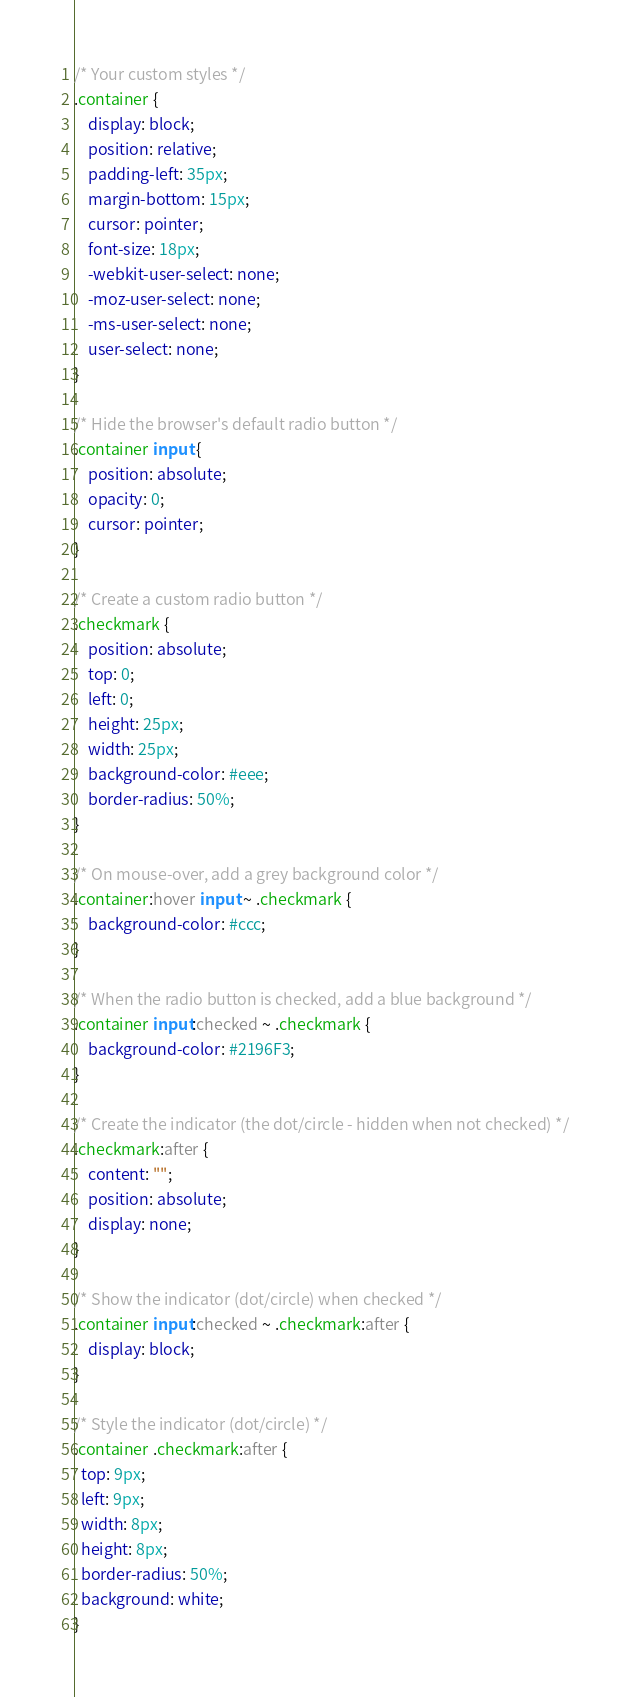<code> <loc_0><loc_0><loc_500><loc_500><_CSS_>/* Your custom styles */
.container {
    display: block;
    position: relative;
    padding-left: 35px;
    margin-bottom: 15px;
    cursor: pointer;
    font-size: 18px;
    -webkit-user-select: none;
    -moz-user-select: none;
    -ms-user-select: none;
    user-select: none;
}

/* Hide the browser's default radio button */
.container input {
    position: absolute;
    opacity: 0;
    cursor: pointer;
}

/* Create a custom radio button */
.checkmark {
    position: absolute;
    top: 0;
    left: 0;
    height: 25px;
    width: 25px;
    background-color: #eee;
    border-radius: 50%;
}

/* On mouse-over, add a grey background color */
.container:hover input ~ .checkmark {
    background-color: #ccc;
}

/* When the radio button is checked, add a blue background */
.container input:checked ~ .checkmark {
    background-color: #2196F3;
}

/* Create the indicator (the dot/circle - hidden when not checked) */
.checkmark:after {
    content: "";
    position: absolute;
    display: none;
}

/* Show the indicator (dot/circle) when checked */
.container input:checked ~ .checkmark:after {
    display: block;
}

/* Style the indicator (dot/circle) */
.container .checkmark:after {
  top: 9px;
  left: 9px;
  width: 8px;
  height: 8px;
  border-radius: 50%;
  background: white;
}
</code> 